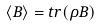<formula> <loc_0><loc_0><loc_500><loc_500>\langle B \rangle = t r ( \rho B )</formula> 